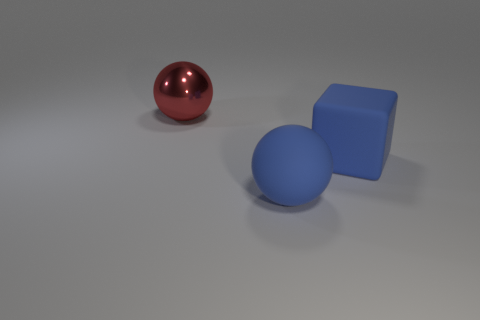There is a sphere that is in front of the metallic object; is its color the same as the rubber thing that is behind the blue rubber sphere?
Ensure brevity in your answer.  Yes. What shape is the matte thing that is the same color as the large rubber sphere?
Your answer should be very brief. Cube. Is there a blue rubber object of the same shape as the metallic object?
Your answer should be compact. Yes. There is a matte block that is the same size as the blue matte ball; what is its color?
Offer a terse response. Blue. The large thing that is right of the sphere that is on the right side of the red ball is what color?
Provide a short and direct response. Blue. There is a big object that is right of the big blue rubber sphere; does it have the same color as the big matte sphere?
Offer a terse response. Yes. The blue matte object that is in front of the big blue matte thing that is behind the sphere in front of the red metallic thing is what shape?
Provide a short and direct response. Sphere. What number of large red things are in front of the ball in front of the large cube?
Offer a very short reply. 0. Do the big cube and the red object have the same material?
Keep it short and to the point. No. How many red metal things are in front of the red sphere that is behind the large blue thing that is to the right of the large matte sphere?
Make the answer very short. 0. 